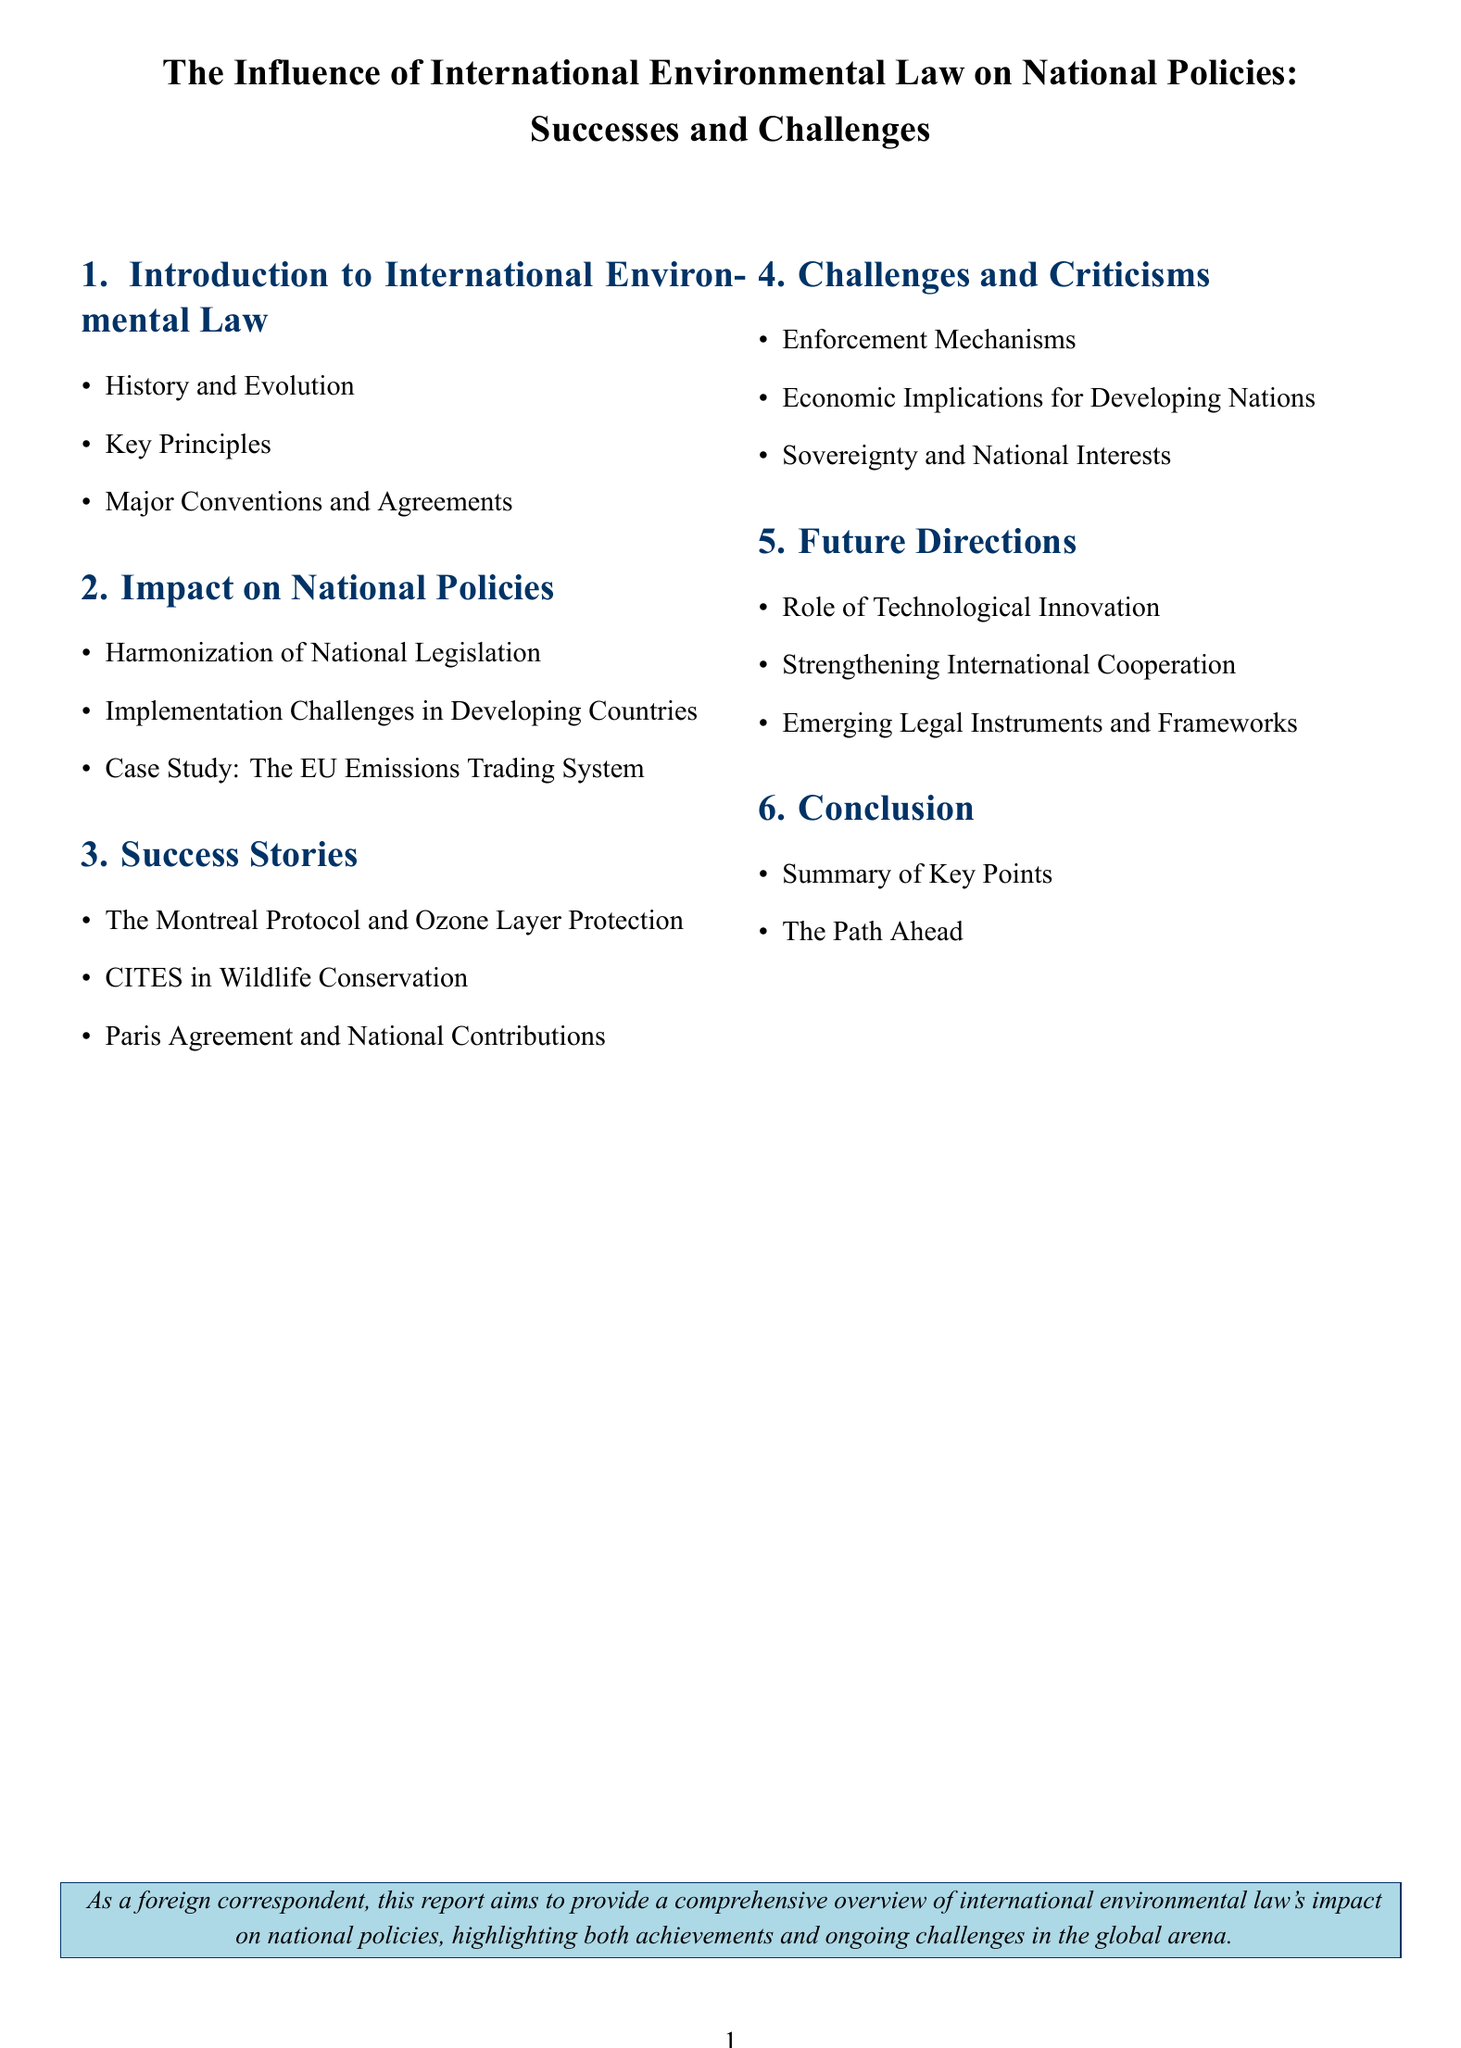What is the title of the document? The title is stated clearly at the beginning of the document, which is "The Influence of International Environmental Law on National Policies: Successes and Challenges."
Answer: The Influence of International Environmental Law on National Policies: Successes and Challenges How many sections are in the document? The total number of sections can be counted from the table of contents, which includes six distinct sections.
Answer: 6 What is the focus of section 2? Section 2 is dedicated to the "Impact on National Policies," which is indicated in the title of the section.
Answer: Impact on National Policies Which protocol is mentioned in the success stories? The success stories section refers specifically to the "Montreal Protocol," highlighting its importance.
Answer: Montreal Protocol What are the themes discussed in section 4? Section 4 covers "Challenges and Criticisms," which is a theme indicated in the section title.
Answer: Challenges and Criticisms What is the purpose of the report as stated at the end? The document explains that its purpose is to provide a comprehensive overview regarding international environmental law's influence and its effects.
Answer: Comprehensive overview of international environmental law's impact What does section 5 describe? Section 5 discusses "Future Directions," which indicates what the document proposes for future actions or considerations.
Answer: Future Directions What kind of case study is mentioned in section 2? A case study referenced in section 2 is "The EU Emissions Trading System," showcasing a practical example.
Answer: The EU Emissions Trading System 